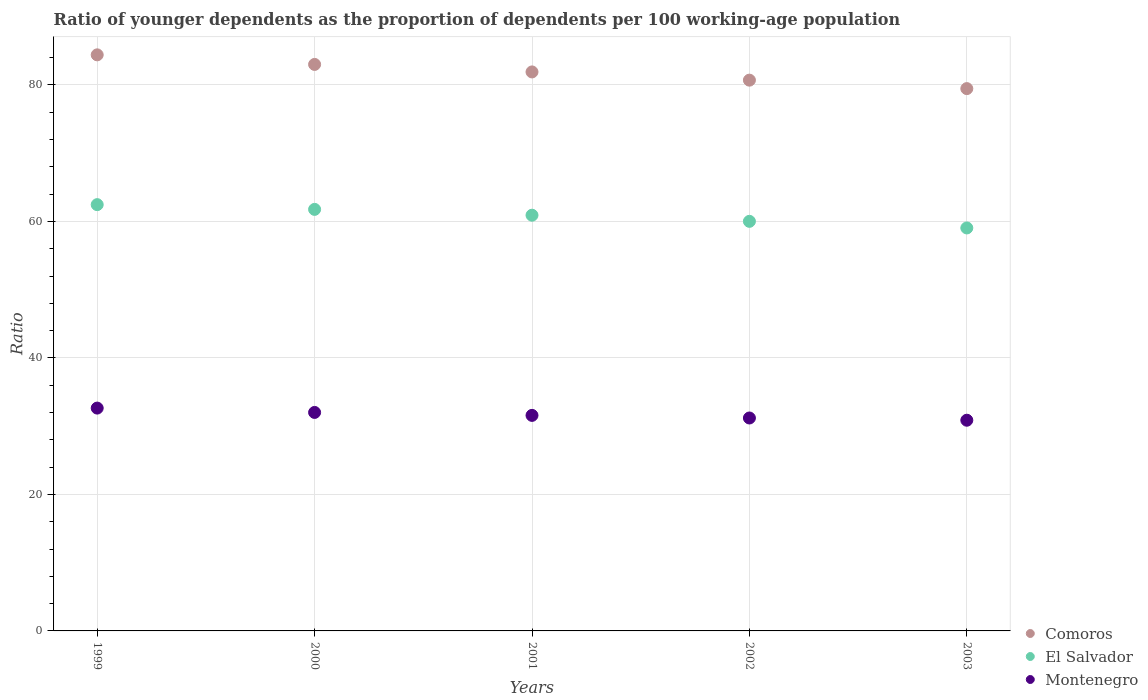How many different coloured dotlines are there?
Offer a very short reply. 3. What is the age dependency ratio(young) in Comoros in 2003?
Your response must be concise. 79.46. Across all years, what is the maximum age dependency ratio(young) in El Salvador?
Give a very brief answer. 62.46. Across all years, what is the minimum age dependency ratio(young) in El Salvador?
Ensure brevity in your answer.  59.05. In which year was the age dependency ratio(young) in El Salvador minimum?
Provide a succinct answer. 2003. What is the total age dependency ratio(young) in Comoros in the graph?
Your response must be concise. 409.49. What is the difference between the age dependency ratio(young) in El Salvador in 1999 and that in 2001?
Give a very brief answer. 1.55. What is the difference between the age dependency ratio(young) in Montenegro in 2003 and the age dependency ratio(young) in El Salvador in 2000?
Your response must be concise. -30.89. What is the average age dependency ratio(young) in El Salvador per year?
Your response must be concise. 60.84. In the year 2002, what is the difference between the age dependency ratio(young) in El Salvador and age dependency ratio(young) in Montenegro?
Your response must be concise. 28.81. In how many years, is the age dependency ratio(young) in Montenegro greater than 20?
Your answer should be very brief. 5. What is the ratio of the age dependency ratio(young) in Comoros in 1999 to that in 2003?
Offer a very short reply. 1.06. Is the age dependency ratio(young) in Montenegro in 1999 less than that in 2002?
Ensure brevity in your answer.  No. What is the difference between the highest and the second highest age dependency ratio(young) in Montenegro?
Offer a terse response. 0.64. What is the difference between the highest and the lowest age dependency ratio(young) in Comoros?
Provide a short and direct response. 4.95. In how many years, is the age dependency ratio(young) in Montenegro greater than the average age dependency ratio(young) in Montenegro taken over all years?
Provide a short and direct response. 2. Is the age dependency ratio(young) in Comoros strictly greater than the age dependency ratio(young) in Montenegro over the years?
Your response must be concise. Yes. Is the age dependency ratio(young) in Montenegro strictly less than the age dependency ratio(young) in Comoros over the years?
Keep it short and to the point. Yes. How many dotlines are there?
Keep it short and to the point. 3. Are the values on the major ticks of Y-axis written in scientific E-notation?
Provide a succinct answer. No. Where does the legend appear in the graph?
Provide a succinct answer. Bottom right. How many legend labels are there?
Offer a very short reply. 3. What is the title of the graph?
Your answer should be compact. Ratio of younger dependents as the proportion of dependents per 100 working-age population. Does "Lower middle income" appear as one of the legend labels in the graph?
Provide a short and direct response. No. What is the label or title of the X-axis?
Your answer should be compact. Years. What is the label or title of the Y-axis?
Provide a succinct answer. Ratio. What is the Ratio of Comoros in 1999?
Keep it short and to the point. 84.41. What is the Ratio of El Salvador in 1999?
Offer a terse response. 62.46. What is the Ratio of Montenegro in 1999?
Provide a succinct answer. 32.65. What is the Ratio of Comoros in 2000?
Keep it short and to the point. 83.01. What is the Ratio of El Salvador in 2000?
Give a very brief answer. 61.77. What is the Ratio of Montenegro in 2000?
Offer a very short reply. 32.01. What is the Ratio of Comoros in 2001?
Your answer should be very brief. 81.91. What is the Ratio of El Salvador in 2001?
Give a very brief answer. 60.91. What is the Ratio in Montenegro in 2001?
Your answer should be compact. 31.58. What is the Ratio in Comoros in 2002?
Your answer should be very brief. 80.7. What is the Ratio of El Salvador in 2002?
Make the answer very short. 60.01. What is the Ratio in Montenegro in 2002?
Offer a terse response. 31.2. What is the Ratio in Comoros in 2003?
Your answer should be very brief. 79.46. What is the Ratio of El Salvador in 2003?
Make the answer very short. 59.05. What is the Ratio of Montenegro in 2003?
Offer a terse response. 30.87. Across all years, what is the maximum Ratio in Comoros?
Your answer should be very brief. 84.41. Across all years, what is the maximum Ratio in El Salvador?
Provide a succinct answer. 62.46. Across all years, what is the maximum Ratio in Montenegro?
Your answer should be compact. 32.65. Across all years, what is the minimum Ratio of Comoros?
Give a very brief answer. 79.46. Across all years, what is the minimum Ratio in El Salvador?
Your response must be concise. 59.05. Across all years, what is the minimum Ratio in Montenegro?
Give a very brief answer. 30.87. What is the total Ratio in Comoros in the graph?
Give a very brief answer. 409.49. What is the total Ratio in El Salvador in the graph?
Offer a terse response. 304.2. What is the total Ratio in Montenegro in the graph?
Your answer should be very brief. 158.32. What is the difference between the Ratio of Comoros in 1999 and that in 2000?
Keep it short and to the point. 1.4. What is the difference between the Ratio in El Salvador in 1999 and that in 2000?
Provide a short and direct response. 0.69. What is the difference between the Ratio in Montenegro in 1999 and that in 2000?
Your answer should be compact. 0.64. What is the difference between the Ratio in Comoros in 1999 and that in 2001?
Offer a very short reply. 2.5. What is the difference between the Ratio in El Salvador in 1999 and that in 2001?
Your response must be concise. 1.55. What is the difference between the Ratio of Montenegro in 1999 and that in 2001?
Offer a very short reply. 1.07. What is the difference between the Ratio of Comoros in 1999 and that in 2002?
Offer a terse response. 3.71. What is the difference between the Ratio in El Salvador in 1999 and that in 2002?
Keep it short and to the point. 2.45. What is the difference between the Ratio of Montenegro in 1999 and that in 2002?
Make the answer very short. 1.45. What is the difference between the Ratio of Comoros in 1999 and that in 2003?
Keep it short and to the point. 4.95. What is the difference between the Ratio of El Salvador in 1999 and that in 2003?
Your answer should be very brief. 3.42. What is the difference between the Ratio in Montenegro in 1999 and that in 2003?
Give a very brief answer. 1.78. What is the difference between the Ratio of Comoros in 2000 and that in 2001?
Make the answer very short. 1.1. What is the difference between the Ratio in El Salvador in 2000 and that in 2001?
Make the answer very short. 0.85. What is the difference between the Ratio in Montenegro in 2000 and that in 2001?
Make the answer very short. 0.43. What is the difference between the Ratio of Comoros in 2000 and that in 2002?
Keep it short and to the point. 2.3. What is the difference between the Ratio in El Salvador in 2000 and that in 2002?
Your answer should be compact. 1.75. What is the difference between the Ratio of Montenegro in 2000 and that in 2002?
Ensure brevity in your answer.  0.81. What is the difference between the Ratio in Comoros in 2000 and that in 2003?
Offer a very short reply. 3.54. What is the difference between the Ratio of El Salvador in 2000 and that in 2003?
Provide a short and direct response. 2.72. What is the difference between the Ratio in Montenegro in 2000 and that in 2003?
Provide a short and direct response. 1.14. What is the difference between the Ratio of Comoros in 2001 and that in 2002?
Offer a terse response. 1.21. What is the difference between the Ratio in El Salvador in 2001 and that in 2002?
Your response must be concise. 0.9. What is the difference between the Ratio in Montenegro in 2001 and that in 2002?
Your answer should be very brief. 0.38. What is the difference between the Ratio in Comoros in 2001 and that in 2003?
Offer a terse response. 2.44. What is the difference between the Ratio of El Salvador in 2001 and that in 2003?
Provide a short and direct response. 1.87. What is the difference between the Ratio in Montenegro in 2001 and that in 2003?
Make the answer very short. 0.71. What is the difference between the Ratio in Comoros in 2002 and that in 2003?
Your answer should be very brief. 1.24. What is the difference between the Ratio of El Salvador in 2002 and that in 2003?
Give a very brief answer. 0.97. What is the difference between the Ratio of Montenegro in 2002 and that in 2003?
Your answer should be compact. 0.33. What is the difference between the Ratio of Comoros in 1999 and the Ratio of El Salvador in 2000?
Offer a terse response. 22.64. What is the difference between the Ratio in Comoros in 1999 and the Ratio in Montenegro in 2000?
Keep it short and to the point. 52.4. What is the difference between the Ratio of El Salvador in 1999 and the Ratio of Montenegro in 2000?
Provide a succinct answer. 30.45. What is the difference between the Ratio in Comoros in 1999 and the Ratio in El Salvador in 2001?
Your response must be concise. 23.5. What is the difference between the Ratio of Comoros in 1999 and the Ratio of Montenegro in 2001?
Your response must be concise. 52.83. What is the difference between the Ratio in El Salvador in 1999 and the Ratio in Montenegro in 2001?
Provide a succinct answer. 30.88. What is the difference between the Ratio of Comoros in 1999 and the Ratio of El Salvador in 2002?
Your answer should be compact. 24.4. What is the difference between the Ratio of Comoros in 1999 and the Ratio of Montenegro in 2002?
Offer a very short reply. 53.21. What is the difference between the Ratio of El Salvador in 1999 and the Ratio of Montenegro in 2002?
Your answer should be compact. 31.26. What is the difference between the Ratio in Comoros in 1999 and the Ratio in El Salvador in 2003?
Offer a terse response. 25.36. What is the difference between the Ratio of Comoros in 1999 and the Ratio of Montenegro in 2003?
Your answer should be compact. 53.54. What is the difference between the Ratio in El Salvador in 1999 and the Ratio in Montenegro in 2003?
Provide a short and direct response. 31.59. What is the difference between the Ratio of Comoros in 2000 and the Ratio of El Salvador in 2001?
Ensure brevity in your answer.  22.09. What is the difference between the Ratio in Comoros in 2000 and the Ratio in Montenegro in 2001?
Ensure brevity in your answer.  51.42. What is the difference between the Ratio of El Salvador in 2000 and the Ratio of Montenegro in 2001?
Provide a short and direct response. 30.18. What is the difference between the Ratio of Comoros in 2000 and the Ratio of El Salvador in 2002?
Make the answer very short. 22.99. What is the difference between the Ratio in Comoros in 2000 and the Ratio in Montenegro in 2002?
Provide a succinct answer. 51.81. What is the difference between the Ratio in El Salvador in 2000 and the Ratio in Montenegro in 2002?
Your answer should be compact. 30.57. What is the difference between the Ratio in Comoros in 2000 and the Ratio in El Salvador in 2003?
Ensure brevity in your answer.  23.96. What is the difference between the Ratio of Comoros in 2000 and the Ratio of Montenegro in 2003?
Keep it short and to the point. 52.13. What is the difference between the Ratio in El Salvador in 2000 and the Ratio in Montenegro in 2003?
Offer a very short reply. 30.89. What is the difference between the Ratio in Comoros in 2001 and the Ratio in El Salvador in 2002?
Provide a succinct answer. 21.89. What is the difference between the Ratio of Comoros in 2001 and the Ratio of Montenegro in 2002?
Offer a terse response. 50.71. What is the difference between the Ratio in El Salvador in 2001 and the Ratio in Montenegro in 2002?
Ensure brevity in your answer.  29.71. What is the difference between the Ratio in Comoros in 2001 and the Ratio in El Salvador in 2003?
Offer a terse response. 22.86. What is the difference between the Ratio of Comoros in 2001 and the Ratio of Montenegro in 2003?
Offer a very short reply. 51.03. What is the difference between the Ratio in El Salvador in 2001 and the Ratio in Montenegro in 2003?
Provide a succinct answer. 30.04. What is the difference between the Ratio in Comoros in 2002 and the Ratio in El Salvador in 2003?
Ensure brevity in your answer.  21.66. What is the difference between the Ratio of Comoros in 2002 and the Ratio of Montenegro in 2003?
Provide a succinct answer. 49.83. What is the difference between the Ratio of El Salvador in 2002 and the Ratio of Montenegro in 2003?
Provide a short and direct response. 29.14. What is the average Ratio in Comoros per year?
Offer a terse response. 81.9. What is the average Ratio of El Salvador per year?
Provide a succinct answer. 60.84. What is the average Ratio in Montenegro per year?
Offer a very short reply. 31.66. In the year 1999, what is the difference between the Ratio of Comoros and Ratio of El Salvador?
Make the answer very short. 21.95. In the year 1999, what is the difference between the Ratio in Comoros and Ratio in Montenegro?
Give a very brief answer. 51.76. In the year 1999, what is the difference between the Ratio in El Salvador and Ratio in Montenegro?
Make the answer very short. 29.81. In the year 2000, what is the difference between the Ratio in Comoros and Ratio in El Salvador?
Provide a short and direct response. 21.24. In the year 2000, what is the difference between the Ratio of Comoros and Ratio of Montenegro?
Your answer should be very brief. 50.99. In the year 2000, what is the difference between the Ratio in El Salvador and Ratio in Montenegro?
Provide a succinct answer. 29.75. In the year 2001, what is the difference between the Ratio in Comoros and Ratio in El Salvador?
Your answer should be compact. 20.99. In the year 2001, what is the difference between the Ratio in Comoros and Ratio in Montenegro?
Give a very brief answer. 50.32. In the year 2001, what is the difference between the Ratio of El Salvador and Ratio of Montenegro?
Your response must be concise. 29.33. In the year 2002, what is the difference between the Ratio in Comoros and Ratio in El Salvador?
Make the answer very short. 20.69. In the year 2002, what is the difference between the Ratio in Comoros and Ratio in Montenegro?
Offer a very short reply. 49.5. In the year 2002, what is the difference between the Ratio in El Salvador and Ratio in Montenegro?
Provide a succinct answer. 28.82. In the year 2003, what is the difference between the Ratio of Comoros and Ratio of El Salvador?
Provide a short and direct response. 20.42. In the year 2003, what is the difference between the Ratio in Comoros and Ratio in Montenegro?
Provide a short and direct response. 48.59. In the year 2003, what is the difference between the Ratio of El Salvador and Ratio of Montenegro?
Keep it short and to the point. 28.17. What is the ratio of the Ratio in Comoros in 1999 to that in 2000?
Give a very brief answer. 1.02. What is the ratio of the Ratio in El Salvador in 1999 to that in 2000?
Ensure brevity in your answer.  1.01. What is the ratio of the Ratio in Montenegro in 1999 to that in 2000?
Provide a short and direct response. 1.02. What is the ratio of the Ratio of Comoros in 1999 to that in 2001?
Provide a short and direct response. 1.03. What is the ratio of the Ratio of El Salvador in 1999 to that in 2001?
Your answer should be very brief. 1.03. What is the ratio of the Ratio of Montenegro in 1999 to that in 2001?
Offer a terse response. 1.03. What is the ratio of the Ratio in Comoros in 1999 to that in 2002?
Your answer should be very brief. 1.05. What is the ratio of the Ratio in El Salvador in 1999 to that in 2002?
Your response must be concise. 1.04. What is the ratio of the Ratio in Montenegro in 1999 to that in 2002?
Provide a succinct answer. 1.05. What is the ratio of the Ratio in Comoros in 1999 to that in 2003?
Your answer should be very brief. 1.06. What is the ratio of the Ratio of El Salvador in 1999 to that in 2003?
Your answer should be compact. 1.06. What is the ratio of the Ratio of Montenegro in 1999 to that in 2003?
Keep it short and to the point. 1.06. What is the ratio of the Ratio of Comoros in 2000 to that in 2001?
Your answer should be very brief. 1.01. What is the ratio of the Ratio of El Salvador in 2000 to that in 2001?
Make the answer very short. 1.01. What is the ratio of the Ratio in Montenegro in 2000 to that in 2001?
Provide a succinct answer. 1.01. What is the ratio of the Ratio in Comoros in 2000 to that in 2002?
Offer a very short reply. 1.03. What is the ratio of the Ratio in El Salvador in 2000 to that in 2002?
Provide a short and direct response. 1.03. What is the ratio of the Ratio of Montenegro in 2000 to that in 2002?
Make the answer very short. 1.03. What is the ratio of the Ratio in Comoros in 2000 to that in 2003?
Your response must be concise. 1.04. What is the ratio of the Ratio in El Salvador in 2000 to that in 2003?
Provide a short and direct response. 1.05. What is the ratio of the Ratio in Comoros in 2001 to that in 2002?
Provide a succinct answer. 1.01. What is the ratio of the Ratio in El Salvador in 2001 to that in 2002?
Offer a very short reply. 1.01. What is the ratio of the Ratio of Montenegro in 2001 to that in 2002?
Give a very brief answer. 1.01. What is the ratio of the Ratio in Comoros in 2001 to that in 2003?
Ensure brevity in your answer.  1.03. What is the ratio of the Ratio of El Salvador in 2001 to that in 2003?
Your response must be concise. 1.03. What is the ratio of the Ratio of Montenegro in 2001 to that in 2003?
Make the answer very short. 1.02. What is the ratio of the Ratio in Comoros in 2002 to that in 2003?
Make the answer very short. 1.02. What is the ratio of the Ratio of El Salvador in 2002 to that in 2003?
Give a very brief answer. 1.02. What is the ratio of the Ratio in Montenegro in 2002 to that in 2003?
Your response must be concise. 1.01. What is the difference between the highest and the second highest Ratio of Comoros?
Make the answer very short. 1.4. What is the difference between the highest and the second highest Ratio of El Salvador?
Your answer should be compact. 0.69. What is the difference between the highest and the second highest Ratio in Montenegro?
Offer a terse response. 0.64. What is the difference between the highest and the lowest Ratio in Comoros?
Offer a very short reply. 4.95. What is the difference between the highest and the lowest Ratio in El Salvador?
Your response must be concise. 3.42. What is the difference between the highest and the lowest Ratio in Montenegro?
Your answer should be compact. 1.78. 